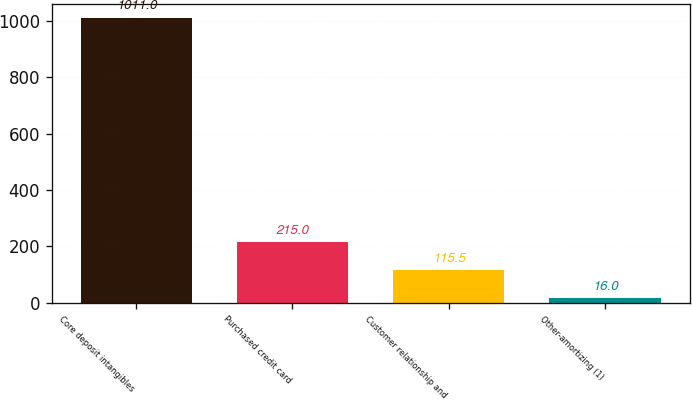Convert chart to OTSL. <chart><loc_0><loc_0><loc_500><loc_500><bar_chart><fcel>Core deposit intangibles<fcel>Purchased credit card<fcel>Customer relationship and<fcel>Other-amortizing (1)<nl><fcel>1011<fcel>215<fcel>115.5<fcel>16<nl></chart> 